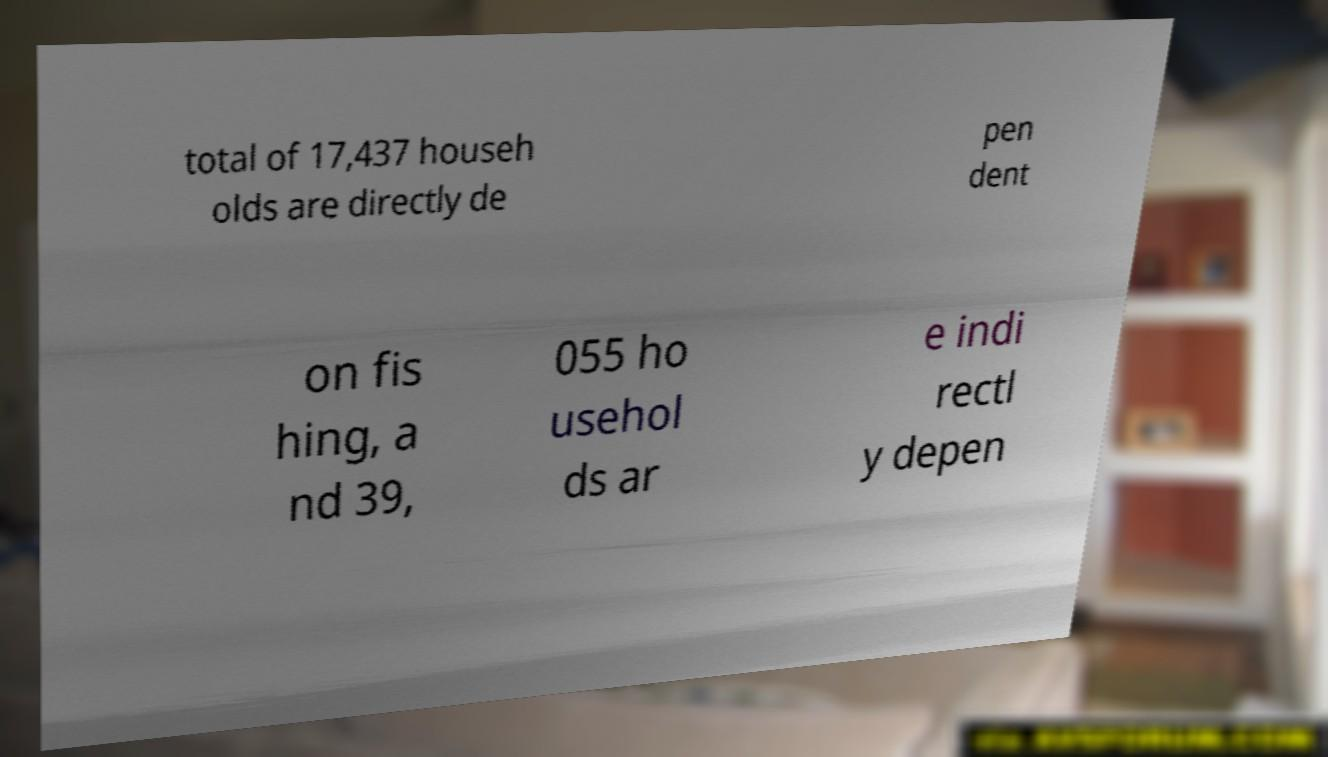Could you extract and type out the text from this image? total of 17,437 househ olds are directly de pen dent on fis hing, a nd 39, 055 ho usehol ds ar e indi rectl y depen 